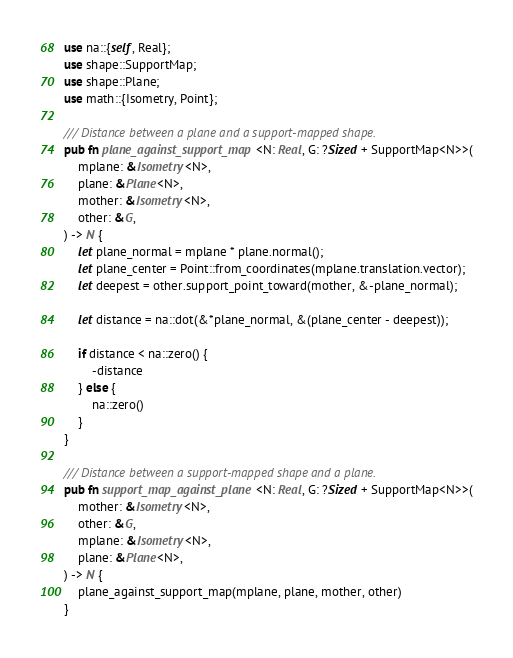<code> <loc_0><loc_0><loc_500><loc_500><_Rust_>use na::{self, Real};
use shape::SupportMap;
use shape::Plane;
use math::{Isometry, Point};

/// Distance between a plane and a support-mapped shape.
pub fn plane_against_support_map<N: Real, G: ?Sized + SupportMap<N>>(
    mplane: &Isometry<N>,
    plane: &Plane<N>,
    mother: &Isometry<N>,
    other: &G,
) -> N {
    let plane_normal = mplane * plane.normal();
    let plane_center = Point::from_coordinates(mplane.translation.vector);
    let deepest = other.support_point_toward(mother, &-plane_normal);

    let distance = na::dot(&*plane_normal, &(plane_center - deepest));

    if distance < na::zero() {
        -distance
    } else {
        na::zero()
    }
}

/// Distance between a support-mapped shape and a plane.
pub fn support_map_against_plane<N: Real, G: ?Sized + SupportMap<N>>(
    mother: &Isometry<N>,
    other: &G,
    mplane: &Isometry<N>,
    plane: &Plane<N>,
) -> N {
    plane_against_support_map(mplane, plane, mother, other)
}
</code> 